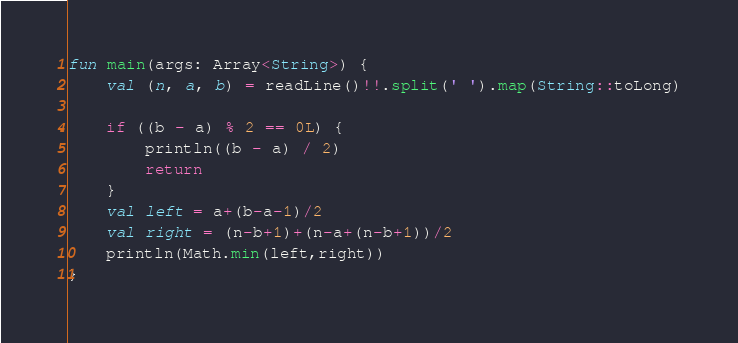Convert code to text. <code><loc_0><loc_0><loc_500><loc_500><_Kotlin_>fun main(args: Array<String>) {
    val (n, a, b) = readLine()!!.split(' ').map(String::toLong)

    if ((b - a) % 2 == 0L) {
        println((b - a) / 2)
        return
    }
    val left = a+(b-a-1)/2
    val right = (n-b+1)+(n-a+(n-b+1))/2
    println(Math.min(left,right))
}</code> 